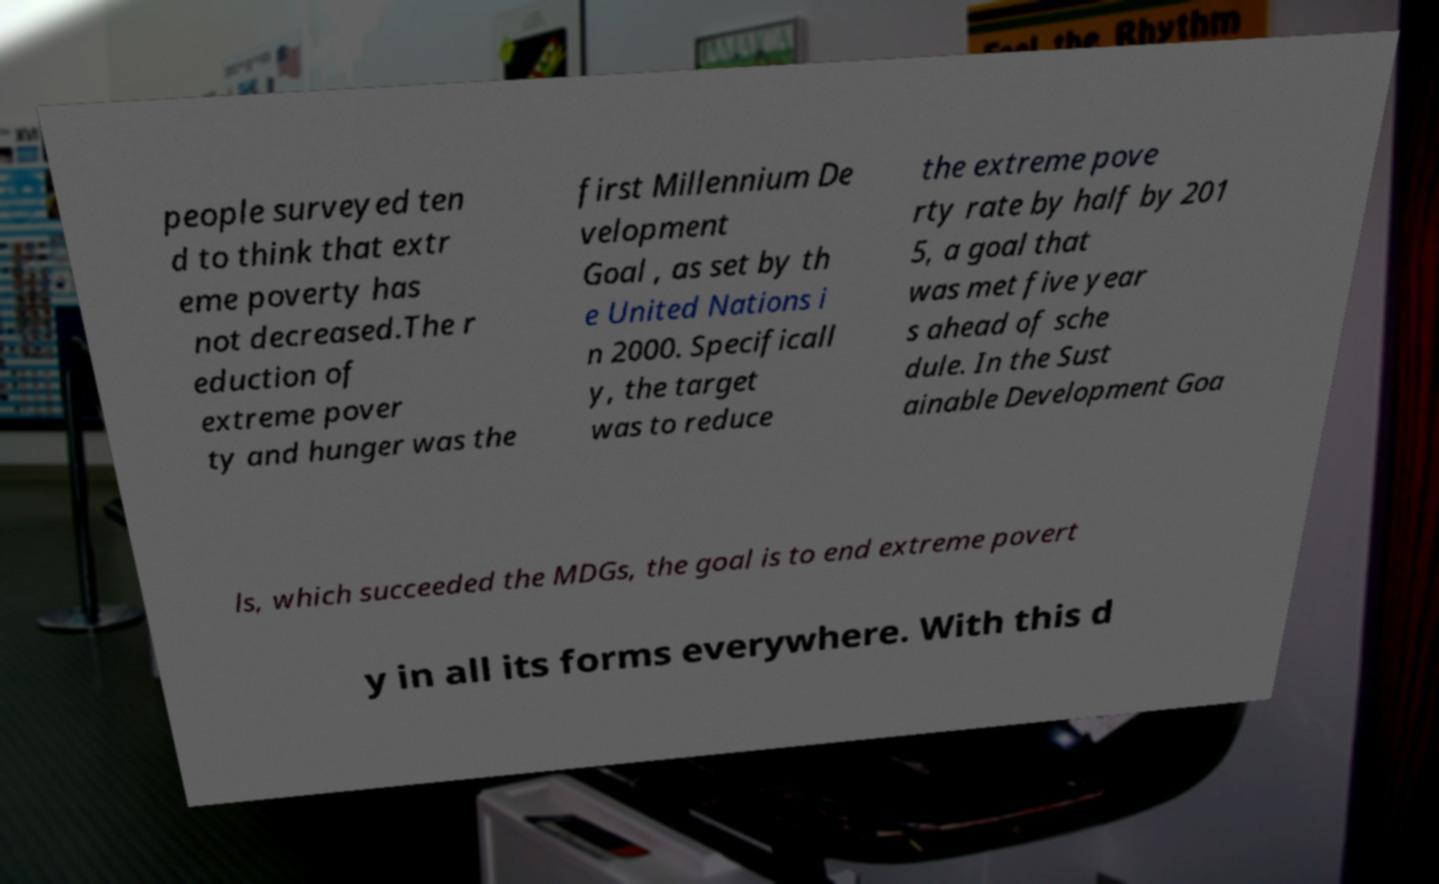Can you accurately transcribe the text from the provided image for me? people surveyed ten d to think that extr eme poverty has not decreased.The r eduction of extreme pover ty and hunger was the first Millennium De velopment Goal , as set by th e United Nations i n 2000. Specificall y, the target was to reduce the extreme pove rty rate by half by 201 5, a goal that was met five year s ahead of sche dule. In the Sust ainable Development Goa ls, which succeeded the MDGs, the goal is to end extreme povert y in all its forms everywhere. With this d 